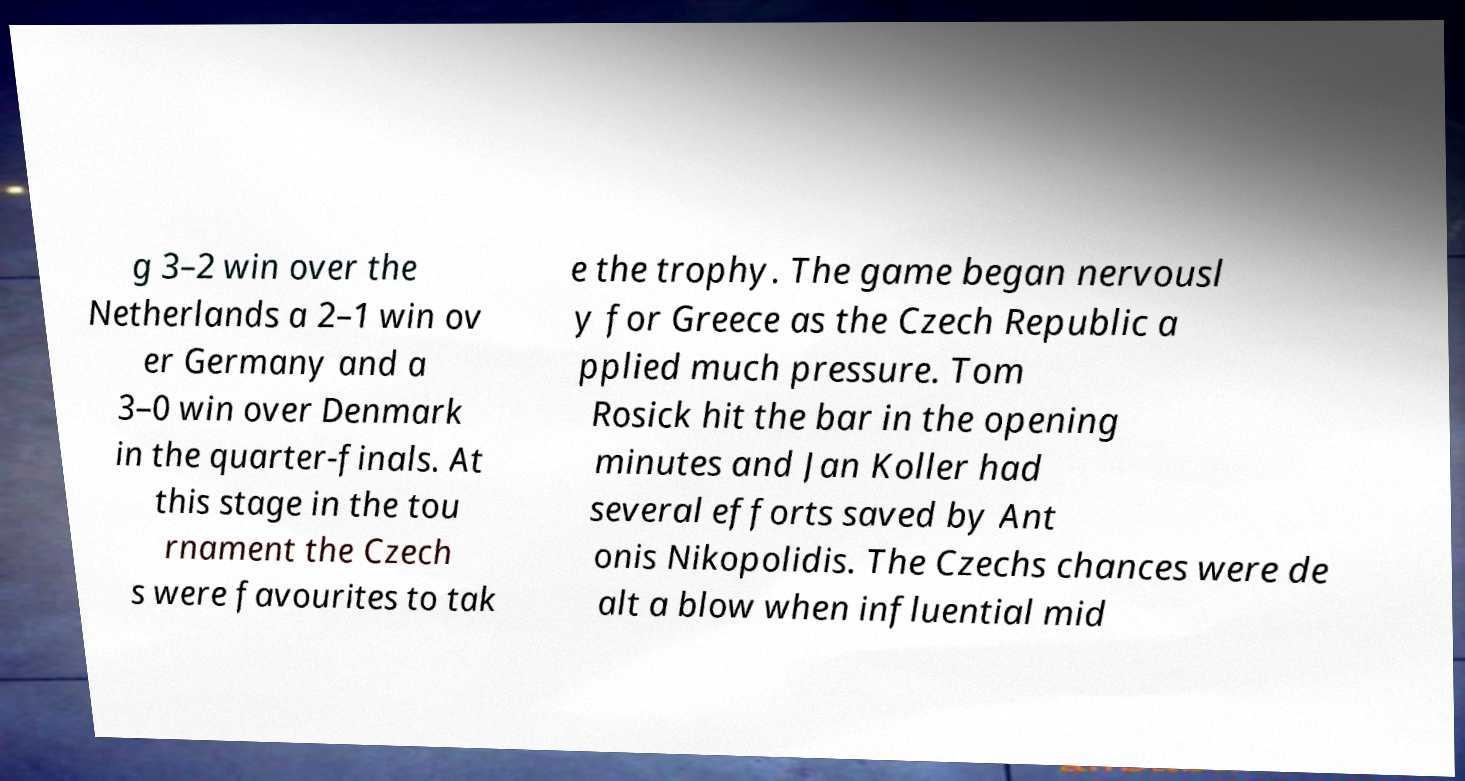Please identify and transcribe the text found in this image. g 3–2 win over the Netherlands a 2–1 win ov er Germany and a 3–0 win over Denmark in the quarter-finals. At this stage in the tou rnament the Czech s were favourites to tak e the trophy. The game began nervousl y for Greece as the Czech Republic a pplied much pressure. Tom Rosick hit the bar in the opening minutes and Jan Koller had several efforts saved by Ant onis Nikopolidis. The Czechs chances were de alt a blow when influential mid 